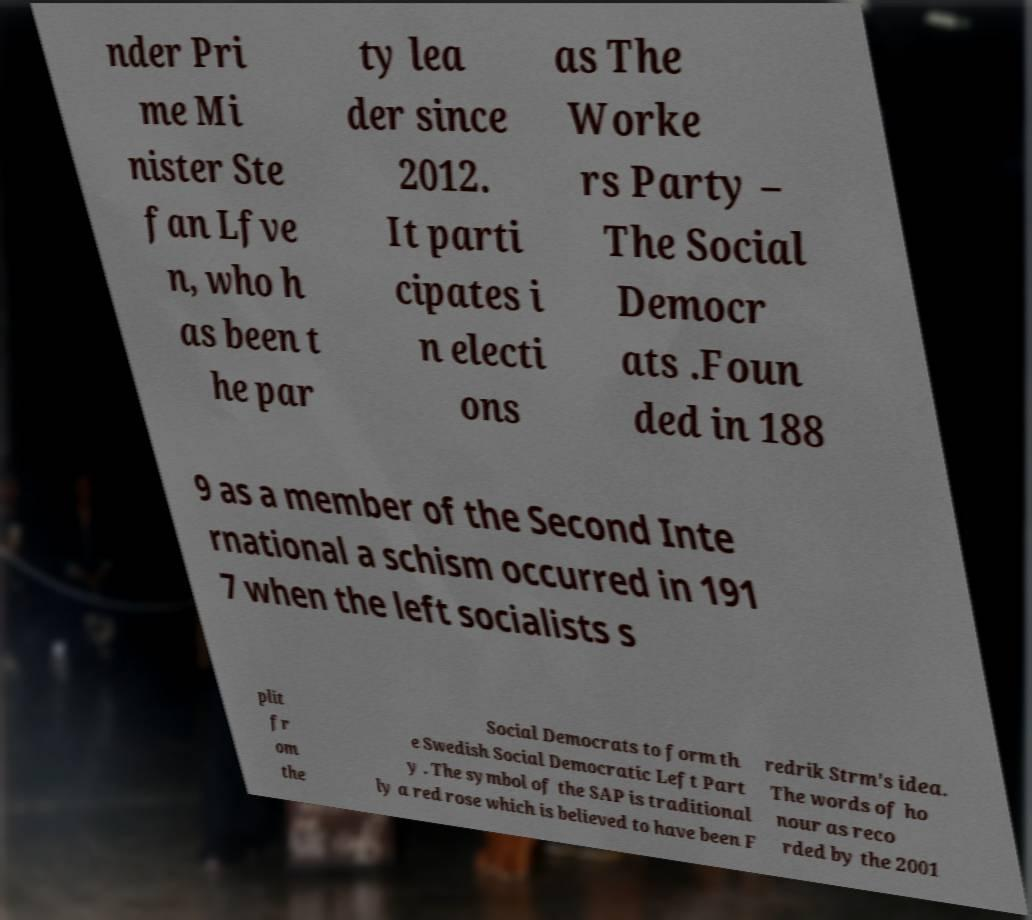I need the written content from this picture converted into text. Can you do that? nder Pri me Mi nister Ste fan Lfve n, who h as been t he par ty lea der since 2012. It parti cipates i n electi ons as The Worke rs Party – The Social Democr ats .Foun ded in 188 9 as a member of the Second Inte rnational a schism occurred in 191 7 when the left socialists s plit fr om the Social Democrats to form th e Swedish Social Democratic Left Part y . The symbol of the SAP is traditional ly a red rose which is believed to have been F redrik Strm's idea. The words of ho nour as reco rded by the 2001 